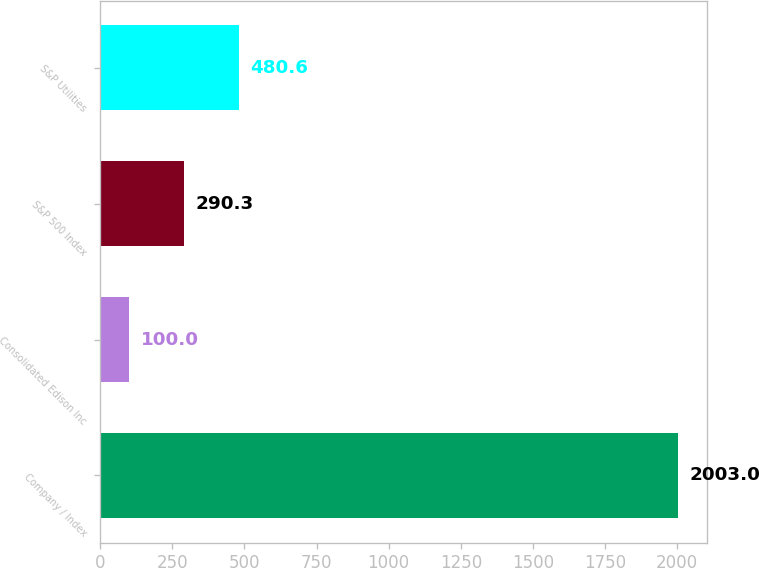<chart> <loc_0><loc_0><loc_500><loc_500><bar_chart><fcel>Company / Index<fcel>Consolidated Edison Inc<fcel>S&P 500 Index<fcel>S&P Utilities<nl><fcel>2003<fcel>100<fcel>290.3<fcel>480.6<nl></chart> 